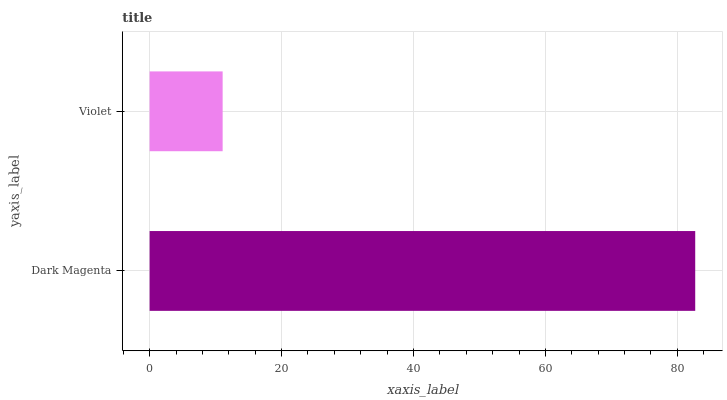Is Violet the minimum?
Answer yes or no. Yes. Is Dark Magenta the maximum?
Answer yes or no. Yes. Is Violet the maximum?
Answer yes or no. No. Is Dark Magenta greater than Violet?
Answer yes or no. Yes. Is Violet less than Dark Magenta?
Answer yes or no. Yes. Is Violet greater than Dark Magenta?
Answer yes or no. No. Is Dark Magenta less than Violet?
Answer yes or no. No. Is Dark Magenta the high median?
Answer yes or no. Yes. Is Violet the low median?
Answer yes or no. Yes. Is Violet the high median?
Answer yes or no. No. Is Dark Magenta the low median?
Answer yes or no. No. 